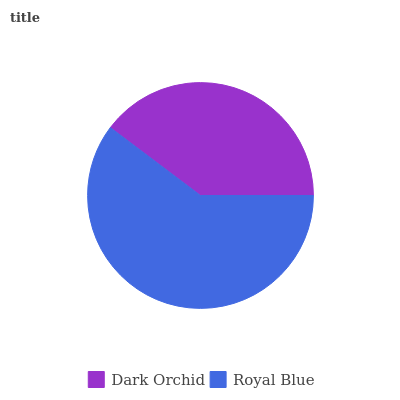Is Dark Orchid the minimum?
Answer yes or no. Yes. Is Royal Blue the maximum?
Answer yes or no. Yes. Is Royal Blue the minimum?
Answer yes or no. No. Is Royal Blue greater than Dark Orchid?
Answer yes or no. Yes. Is Dark Orchid less than Royal Blue?
Answer yes or no. Yes. Is Dark Orchid greater than Royal Blue?
Answer yes or no. No. Is Royal Blue less than Dark Orchid?
Answer yes or no. No. Is Royal Blue the high median?
Answer yes or no. Yes. Is Dark Orchid the low median?
Answer yes or no. Yes. Is Dark Orchid the high median?
Answer yes or no. No. Is Royal Blue the low median?
Answer yes or no. No. 